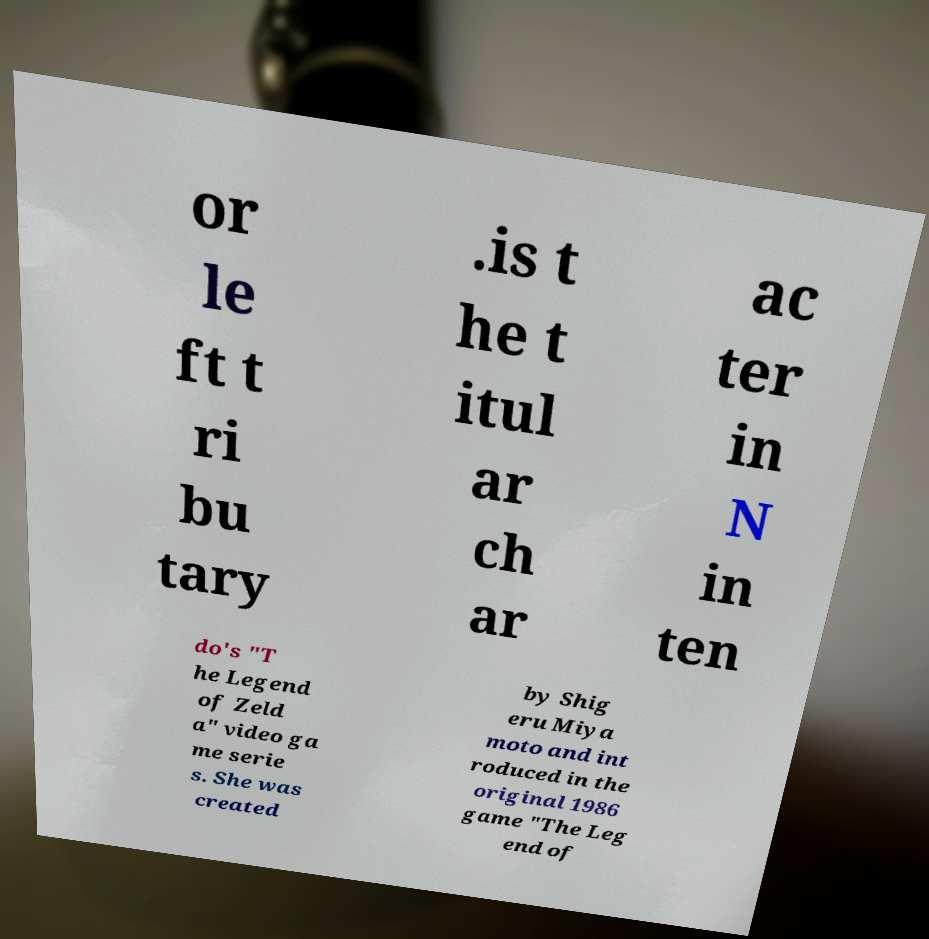Please identify and transcribe the text found in this image. or le ft t ri bu tary .is t he t itul ar ch ar ac ter in N in ten do's "T he Legend of Zeld a" video ga me serie s. She was created by Shig eru Miya moto and int roduced in the original 1986 game "The Leg end of 